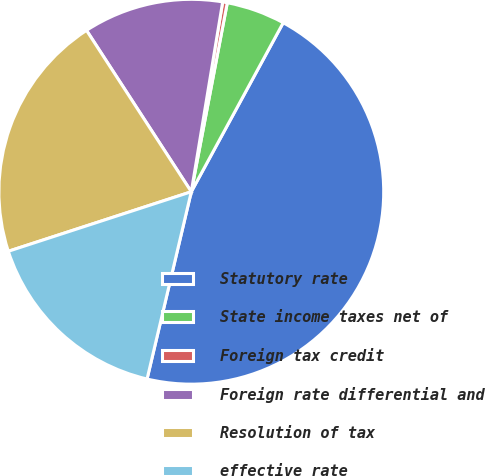<chart> <loc_0><loc_0><loc_500><loc_500><pie_chart><fcel>Statutory rate<fcel>State income taxes net of<fcel>Foreign tax credit<fcel>Foreign rate differential and<fcel>Resolution of tax<fcel>effective rate<nl><fcel>45.76%<fcel>4.93%<fcel>0.39%<fcel>11.77%<fcel>20.84%<fcel>16.3%<nl></chart> 